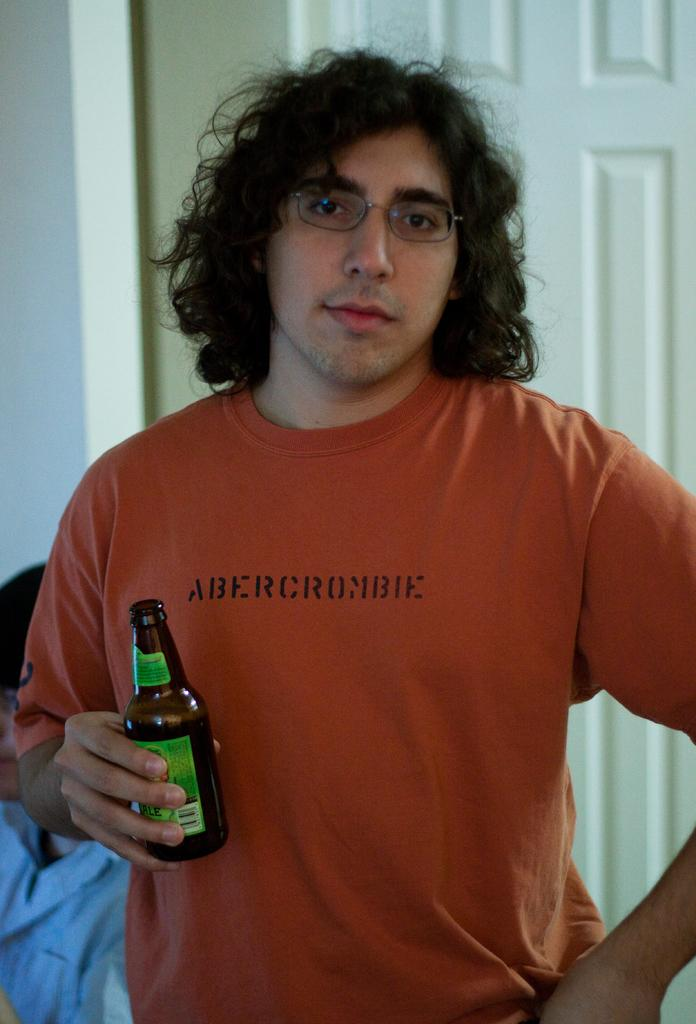How many men are in the image? There are two men in the image. What is one of the men doing in the image? One man is standing in the middle of the image, holding a bottle in his hand. Where is the other man located in the image? Another man is sitting in the background of the image. What can be seen in the background of the image? There is a wall and a door in the background of the image. What type of fish can be seen swimming in the background of the image? There are no fish present in the image; it features two men and a wall with a door in the background. 